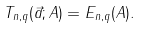<formula> <loc_0><loc_0><loc_500><loc_500>T _ { n , q } ( \vec { a } ; A ) = E _ { n , q } ( A ) .</formula> 